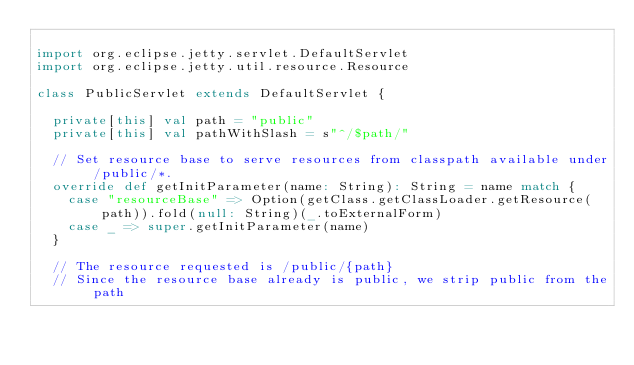<code> <loc_0><loc_0><loc_500><loc_500><_Scala_>
import org.eclipse.jetty.servlet.DefaultServlet
import org.eclipse.jetty.util.resource.Resource

class PublicServlet extends DefaultServlet {

  private[this] val path = "public"
  private[this] val pathWithSlash = s"^/$path/"

  // Set resource base to serve resources from classpath available under /public/*.
  override def getInitParameter(name: String): String = name match {
    case "resourceBase" => Option(getClass.getClassLoader.getResource(path)).fold(null: String)(_.toExternalForm)
    case _ => super.getInitParameter(name)
  }

  // The resource requested is /public/{path}
  // Since the resource base already is public, we strip public from the path</code> 